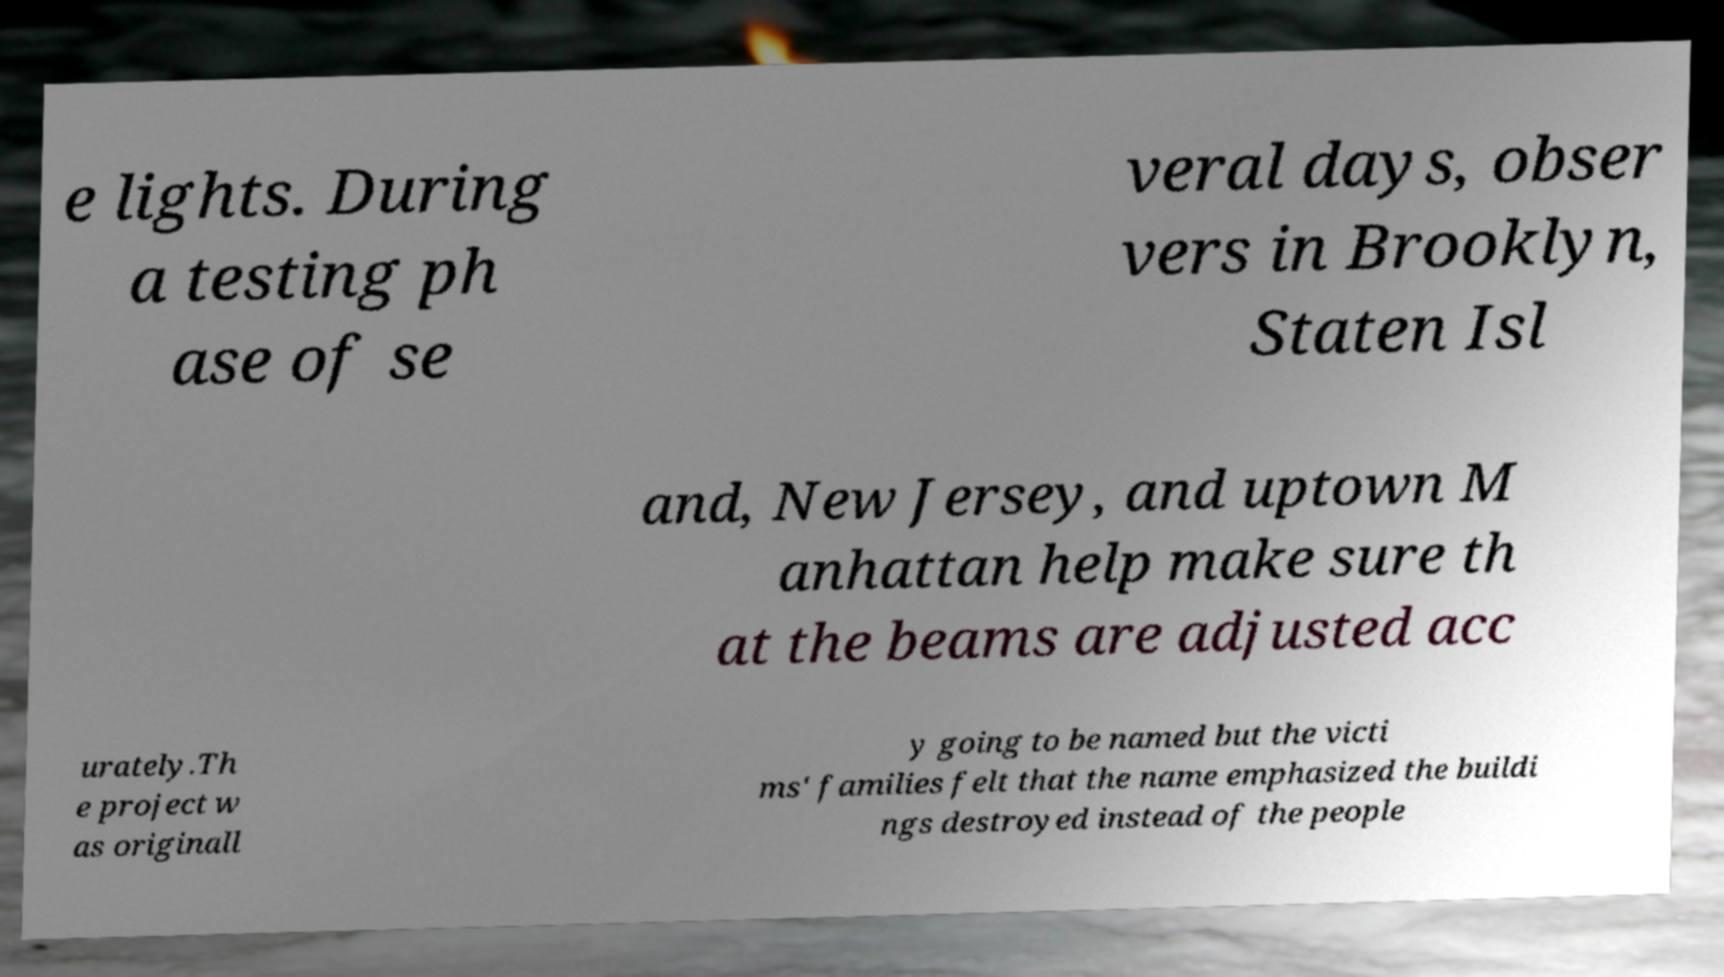Please identify and transcribe the text found in this image. e lights. During a testing ph ase of se veral days, obser vers in Brooklyn, Staten Isl and, New Jersey, and uptown M anhattan help make sure th at the beams are adjusted acc urately.Th e project w as originall y going to be named but the victi ms' families felt that the name emphasized the buildi ngs destroyed instead of the people 